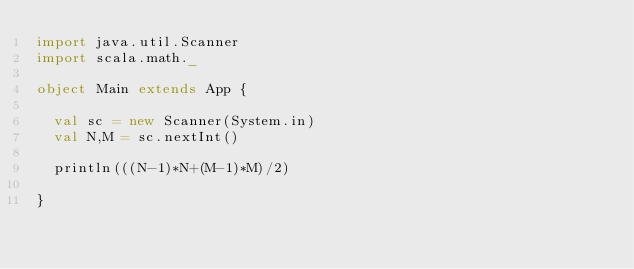<code> <loc_0><loc_0><loc_500><loc_500><_Scala_>import java.util.Scanner
import scala.math._

object Main extends App {

  val sc = new Scanner(System.in)
  val N,M = sc.nextInt()

  println(((N-1)*N+(M-1)*M)/2)

}

</code> 